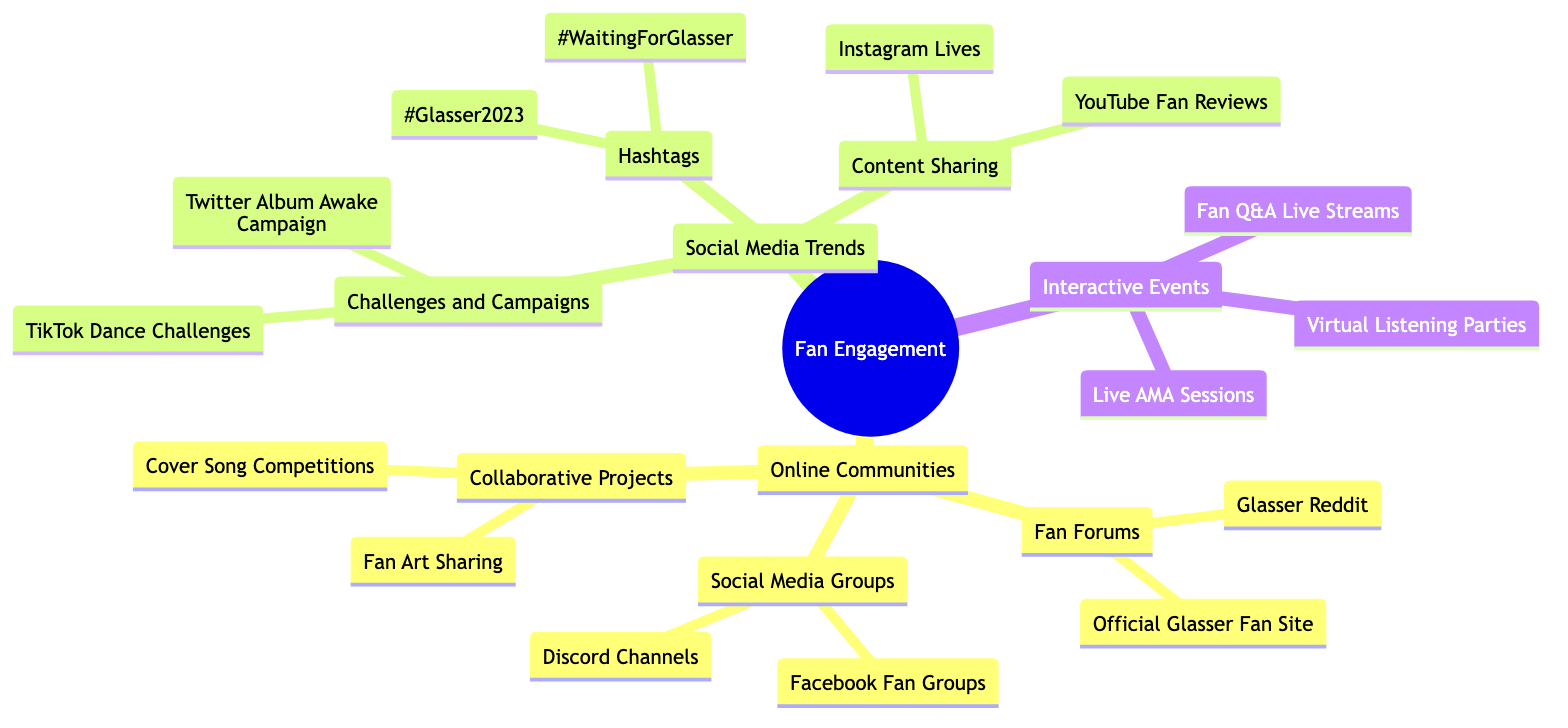What are the two main categories under Fan Engagement? The diagram shows that Fan Engagement is divided into two main categories: Online Communities and Social Media Trends.
Answer: Online Communities, Social Media Trends How many types of Online Communities are there? The diagram illustrates three types of Online Communities: Fan Forums, Social Media Groups, and Collaborative Projects. Therefore, the count is three.
Answer: 3 Which social media platform is mentioned in the Hashtags section? The diagram indicates that the hashtags #WaitingForGlasser and #Glasser2023 are associated with Glasser, highlighting their relevance in social media discussions.
Answer: #WaitingForGlasser, #Glasser2023 What type of event is a Live AMA Session categorized under? According to the diagram, Live AMA Sessions are classified within the category of Interactive Events, which focuses on direct engagement with fans.
Answer: Interactive Events What is one of the Collaborative Projects fans can participate in? The diagram mentions Fan Art Sharing as one of the Collaborative Projects that fans can engage in, showcasing the creative community surrounding Glasser.
Answer: Fan Art Sharing How are TikTok activities categorized in the diagram? In the diagram, TikTok activities are grouped under Challenges and Campaigns within Social Media Trends, indicating a trend for fan engagement through challenges on the platform.
Answer: Challenges and Campaigns What type of content sharing is highlighted in the diagram? The Content Sharing section of the diagram includes Instagram Lives and YouTube Fan Reviews, representing ways fans share content related to Glasser.
Answer: Instagram Lives, YouTube Fan Reviews How many platforms are listed under Fan Forums? The diagram specifies two platforms under Fan Forums: Glasser Reddit and Official Glasser Fan Site, making the total count two.
Answer: 2 What is a common theme in the categories of Interactive Events? Interactive Events such as Virtual Listening Parties, Live AMA Sessions, and Fan Q&A Live Streams all involve fan interaction and live engagement with Glasser’s content.
Answer: Engagement Which term represents a common social media activity fans can do related to Glasser? The hashtag #Glasser2023 represents a common social media activity where fans discuss or share posts related to Glasser's latest updates.
Answer: #Glasser2023 